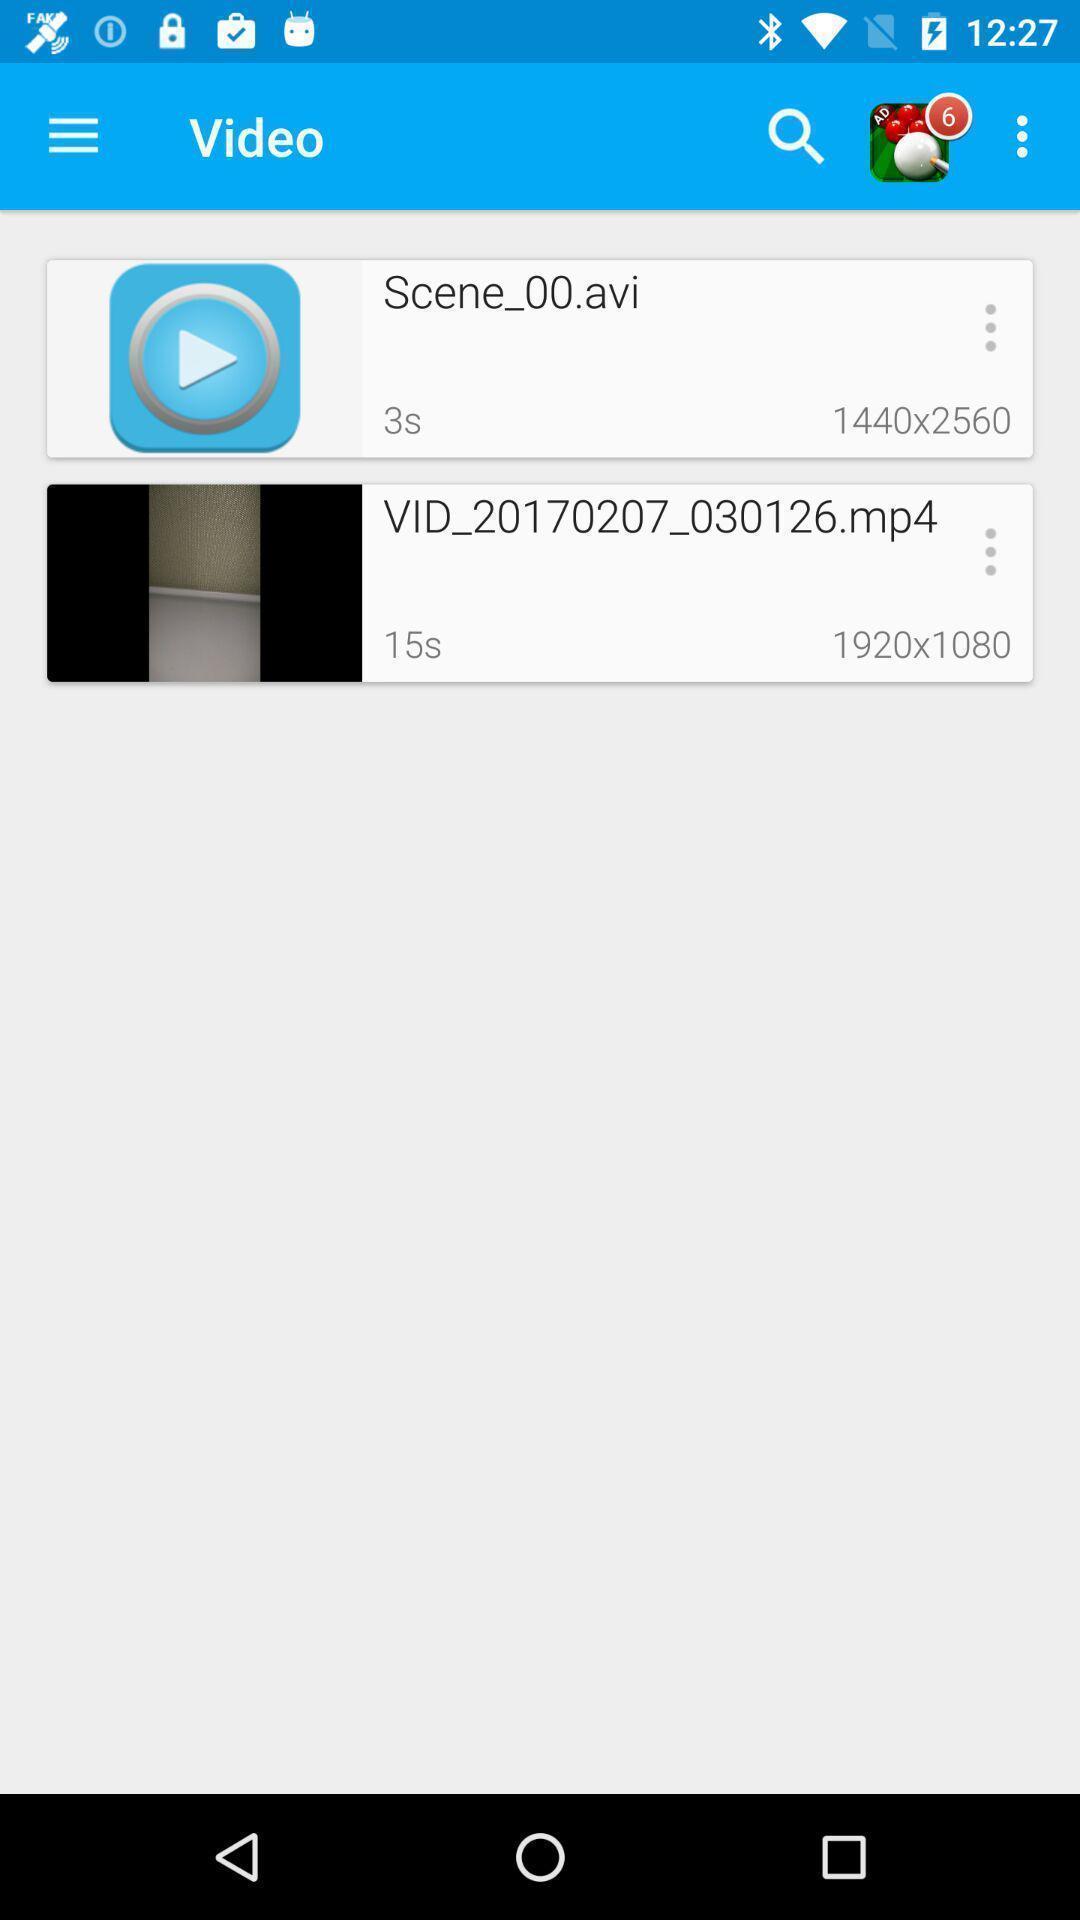What is the overall content of this screenshot? Page displaying various videos. 